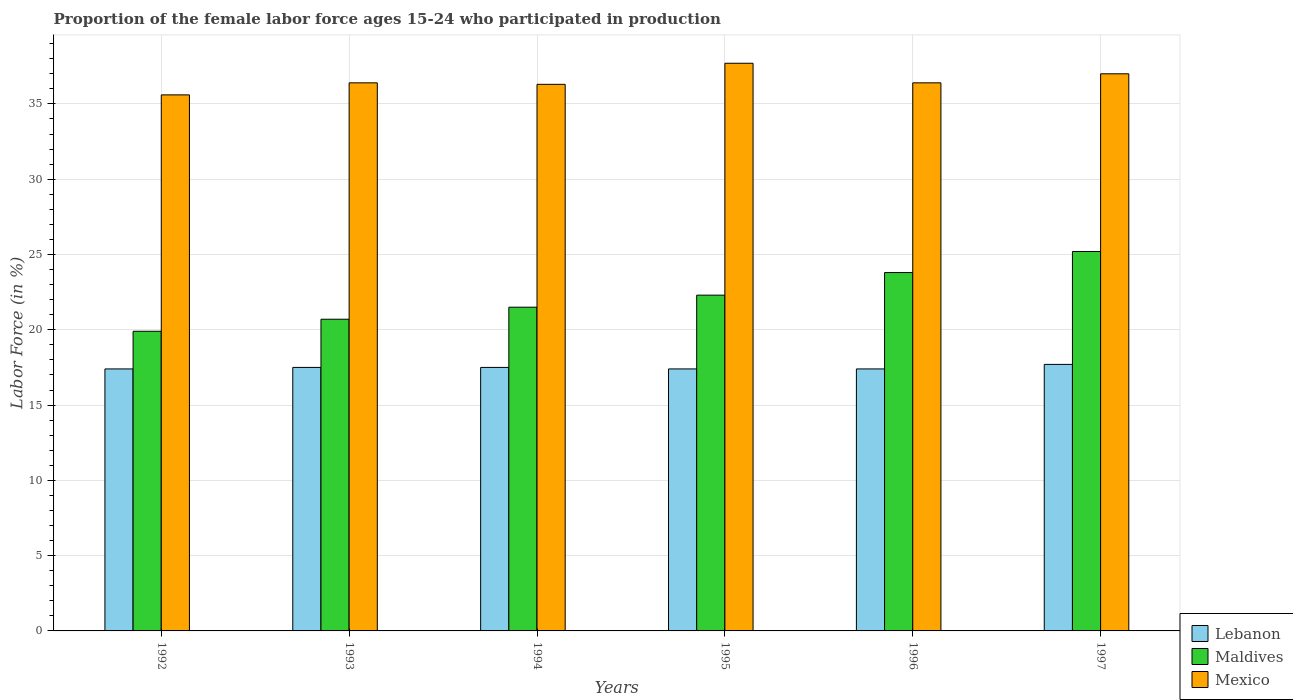How many different coloured bars are there?
Keep it short and to the point. 3. Are the number of bars per tick equal to the number of legend labels?
Provide a short and direct response. Yes. How many bars are there on the 2nd tick from the left?
Ensure brevity in your answer.  3. How many bars are there on the 4th tick from the right?
Give a very brief answer. 3. What is the proportion of the female labor force who participated in production in Mexico in 1994?
Make the answer very short. 36.3. Across all years, what is the maximum proportion of the female labor force who participated in production in Lebanon?
Give a very brief answer. 17.7. Across all years, what is the minimum proportion of the female labor force who participated in production in Maldives?
Keep it short and to the point. 19.9. In which year was the proportion of the female labor force who participated in production in Lebanon minimum?
Make the answer very short. 1992. What is the total proportion of the female labor force who participated in production in Lebanon in the graph?
Offer a terse response. 104.9. What is the difference between the proportion of the female labor force who participated in production in Maldives in 1992 and that in 1996?
Offer a very short reply. -3.9. What is the difference between the proportion of the female labor force who participated in production in Maldives in 1996 and the proportion of the female labor force who participated in production in Mexico in 1995?
Offer a very short reply. -13.9. What is the average proportion of the female labor force who participated in production in Lebanon per year?
Offer a terse response. 17.48. In the year 1994, what is the difference between the proportion of the female labor force who participated in production in Mexico and proportion of the female labor force who participated in production in Lebanon?
Offer a very short reply. 18.8. What is the ratio of the proportion of the female labor force who participated in production in Mexico in 1993 to that in 1996?
Ensure brevity in your answer.  1. What is the difference between the highest and the second highest proportion of the female labor force who participated in production in Maldives?
Ensure brevity in your answer.  1.4. What is the difference between the highest and the lowest proportion of the female labor force who participated in production in Maldives?
Your answer should be compact. 5.3. What does the 2nd bar from the left in 1995 represents?
Ensure brevity in your answer.  Maldives. What does the 2nd bar from the right in 1992 represents?
Your answer should be very brief. Maldives. Is it the case that in every year, the sum of the proportion of the female labor force who participated in production in Maldives and proportion of the female labor force who participated in production in Mexico is greater than the proportion of the female labor force who participated in production in Lebanon?
Ensure brevity in your answer.  Yes. Are all the bars in the graph horizontal?
Your answer should be compact. No. Does the graph contain any zero values?
Offer a terse response. No. What is the title of the graph?
Offer a very short reply. Proportion of the female labor force ages 15-24 who participated in production. What is the label or title of the Y-axis?
Offer a very short reply. Labor Force (in %). What is the Labor Force (in %) in Lebanon in 1992?
Your answer should be very brief. 17.4. What is the Labor Force (in %) in Maldives in 1992?
Give a very brief answer. 19.9. What is the Labor Force (in %) of Mexico in 1992?
Offer a very short reply. 35.6. What is the Labor Force (in %) in Lebanon in 1993?
Keep it short and to the point. 17.5. What is the Labor Force (in %) in Maldives in 1993?
Your response must be concise. 20.7. What is the Labor Force (in %) of Mexico in 1993?
Offer a terse response. 36.4. What is the Labor Force (in %) of Mexico in 1994?
Offer a very short reply. 36.3. What is the Labor Force (in %) in Lebanon in 1995?
Your answer should be compact. 17.4. What is the Labor Force (in %) in Maldives in 1995?
Provide a succinct answer. 22.3. What is the Labor Force (in %) in Mexico in 1995?
Your response must be concise. 37.7. What is the Labor Force (in %) in Lebanon in 1996?
Provide a succinct answer. 17.4. What is the Labor Force (in %) of Maldives in 1996?
Ensure brevity in your answer.  23.8. What is the Labor Force (in %) of Mexico in 1996?
Ensure brevity in your answer.  36.4. What is the Labor Force (in %) of Lebanon in 1997?
Make the answer very short. 17.7. What is the Labor Force (in %) of Maldives in 1997?
Your answer should be compact. 25.2. What is the Labor Force (in %) of Mexico in 1997?
Provide a short and direct response. 37. Across all years, what is the maximum Labor Force (in %) in Lebanon?
Make the answer very short. 17.7. Across all years, what is the maximum Labor Force (in %) of Maldives?
Your answer should be very brief. 25.2. Across all years, what is the maximum Labor Force (in %) in Mexico?
Offer a terse response. 37.7. Across all years, what is the minimum Labor Force (in %) of Lebanon?
Your answer should be very brief. 17.4. Across all years, what is the minimum Labor Force (in %) in Maldives?
Keep it short and to the point. 19.9. Across all years, what is the minimum Labor Force (in %) in Mexico?
Ensure brevity in your answer.  35.6. What is the total Labor Force (in %) of Lebanon in the graph?
Ensure brevity in your answer.  104.9. What is the total Labor Force (in %) of Maldives in the graph?
Provide a short and direct response. 133.4. What is the total Labor Force (in %) in Mexico in the graph?
Your response must be concise. 219.4. What is the difference between the Labor Force (in %) of Lebanon in 1992 and that in 1995?
Ensure brevity in your answer.  0. What is the difference between the Labor Force (in %) in Mexico in 1992 and that in 1995?
Give a very brief answer. -2.1. What is the difference between the Labor Force (in %) in Mexico in 1992 and that in 1997?
Make the answer very short. -1.4. What is the difference between the Labor Force (in %) in Lebanon in 1993 and that in 1994?
Your response must be concise. 0. What is the difference between the Labor Force (in %) of Mexico in 1993 and that in 1994?
Your answer should be compact. 0.1. What is the difference between the Labor Force (in %) of Lebanon in 1993 and that in 1995?
Keep it short and to the point. 0.1. What is the difference between the Labor Force (in %) of Mexico in 1993 and that in 1996?
Your answer should be very brief. 0. What is the difference between the Labor Force (in %) in Lebanon in 1993 and that in 1997?
Make the answer very short. -0.2. What is the difference between the Labor Force (in %) in Mexico in 1993 and that in 1997?
Offer a terse response. -0.6. What is the difference between the Labor Force (in %) in Lebanon in 1994 and that in 1995?
Offer a terse response. 0.1. What is the difference between the Labor Force (in %) of Maldives in 1994 and that in 1995?
Keep it short and to the point. -0.8. What is the difference between the Labor Force (in %) in Lebanon in 1994 and that in 1997?
Your answer should be very brief. -0.2. What is the difference between the Labor Force (in %) in Mexico in 1994 and that in 1997?
Your response must be concise. -0.7. What is the difference between the Labor Force (in %) of Maldives in 1995 and that in 1996?
Your response must be concise. -1.5. What is the difference between the Labor Force (in %) in Mexico in 1995 and that in 1996?
Give a very brief answer. 1.3. What is the difference between the Labor Force (in %) in Lebanon in 1995 and that in 1997?
Ensure brevity in your answer.  -0.3. What is the difference between the Labor Force (in %) in Lebanon in 1996 and that in 1997?
Give a very brief answer. -0.3. What is the difference between the Labor Force (in %) of Maldives in 1996 and that in 1997?
Your answer should be compact. -1.4. What is the difference between the Labor Force (in %) in Lebanon in 1992 and the Labor Force (in %) in Maldives in 1993?
Ensure brevity in your answer.  -3.3. What is the difference between the Labor Force (in %) in Lebanon in 1992 and the Labor Force (in %) in Mexico in 1993?
Give a very brief answer. -19. What is the difference between the Labor Force (in %) of Maldives in 1992 and the Labor Force (in %) of Mexico in 1993?
Make the answer very short. -16.5. What is the difference between the Labor Force (in %) of Lebanon in 1992 and the Labor Force (in %) of Maldives in 1994?
Keep it short and to the point. -4.1. What is the difference between the Labor Force (in %) of Lebanon in 1992 and the Labor Force (in %) of Mexico in 1994?
Ensure brevity in your answer.  -18.9. What is the difference between the Labor Force (in %) in Maldives in 1992 and the Labor Force (in %) in Mexico in 1994?
Your answer should be very brief. -16.4. What is the difference between the Labor Force (in %) of Lebanon in 1992 and the Labor Force (in %) of Mexico in 1995?
Offer a terse response. -20.3. What is the difference between the Labor Force (in %) of Maldives in 1992 and the Labor Force (in %) of Mexico in 1995?
Give a very brief answer. -17.8. What is the difference between the Labor Force (in %) of Maldives in 1992 and the Labor Force (in %) of Mexico in 1996?
Make the answer very short. -16.5. What is the difference between the Labor Force (in %) of Lebanon in 1992 and the Labor Force (in %) of Mexico in 1997?
Ensure brevity in your answer.  -19.6. What is the difference between the Labor Force (in %) of Maldives in 1992 and the Labor Force (in %) of Mexico in 1997?
Your answer should be compact. -17.1. What is the difference between the Labor Force (in %) of Lebanon in 1993 and the Labor Force (in %) of Maldives in 1994?
Make the answer very short. -4. What is the difference between the Labor Force (in %) of Lebanon in 1993 and the Labor Force (in %) of Mexico in 1994?
Keep it short and to the point. -18.8. What is the difference between the Labor Force (in %) of Maldives in 1993 and the Labor Force (in %) of Mexico in 1994?
Ensure brevity in your answer.  -15.6. What is the difference between the Labor Force (in %) of Lebanon in 1993 and the Labor Force (in %) of Mexico in 1995?
Give a very brief answer. -20.2. What is the difference between the Labor Force (in %) of Lebanon in 1993 and the Labor Force (in %) of Mexico in 1996?
Give a very brief answer. -18.9. What is the difference between the Labor Force (in %) in Maldives in 1993 and the Labor Force (in %) in Mexico in 1996?
Offer a terse response. -15.7. What is the difference between the Labor Force (in %) of Lebanon in 1993 and the Labor Force (in %) of Mexico in 1997?
Give a very brief answer. -19.5. What is the difference between the Labor Force (in %) of Maldives in 1993 and the Labor Force (in %) of Mexico in 1997?
Provide a short and direct response. -16.3. What is the difference between the Labor Force (in %) in Lebanon in 1994 and the Labor Force (in %) in Maldives in 1995?
Give a very brief answer. -4.8. What is the difference between the Labor Force (in %) in Lebanon in 1994 and the Labor Force (in %) in Mexico in 1995?
Ensure brevity in your answer.  -20.2. What is the difference between the Labor Force (in %) in Maldives in 1994 and the Labor Force (in %) in Mexico in 1995?
Offer a terse response. -16.2. What is the difference between the Labor Force (in %) of Lebanon in 1994 and the Labor Force (in %) of Mexico in 1996?
Make the answer very short. -18.9. What is the difference between the Labor Force (in %) of Maldives in 1994 and the Labor Force (in %) of Mexico in 1996?
Provide a succinct answer. -14.9. What is the difference between the Labor Force (in %) in Lebanon in 1994 and the Labor Force (in %) in Maldives in 1997?
Your answer should be very brief. -7.7. What is the difference between the Labor Force (in %) in Lebanon in 1994 and the Labor Force (in %) in Mexico in 1997?
Provide a short and direct response. -19.5. What is the difference between the Labor Force (in %) in Maldives in 1994 and the Labor Force (in %) in Mexico in 1997?
Provide a short and direct response. -15.5. What is the difference between the Labor Force (in %) in Lebanon in 1995 and the Labor Force (in %) in Maldives in 1996?
Offer a very short reply. -6.4. What is the difference between the Labor Force (in %) of Lebanon in 1995 and the Labor Force (in %) of Mexico in 1996?
Ensure brevity in your answer.  -19. What is the difference between the Labor Force (in %) in Maldives in 1995 and the Labor Force (in %) in Mexico in 1996?
Offer a very short reply. -14.1. What is the difference between the Labor Force (in %) in Lebanon in 1995 and the Labor Force (in %) in Mexico in 1997?
Your answer should be compact. -19.6. What is the difference between the Labor Force (in %) in Maldives in 1995 and the Labor Force (in %) in Mexico in 1997?
Your answer should be compact. -14.7. What is the difference between the Labor Force (in %) of Lebanon in 1996 and the Labor Force (in %) of Maldives in 1997?
Make the answer very short. -7.8. What is the difference between the Labor Force (in %) in Lebanon in 1996 and the Labor Force (in %) in Mexico in 1997?
Your response must be concise. -19.6. What is the difference between the Labor Force (in %) in Maldives in 1996 and the Labor Force (in %) in Mexico in 1997?
Make the answer very short. -13.2. What is the average Labor Force (in %) in Lebanon per year?
Your response must be concise. 17.48. What is the average Labor Force (in %) of Maldives per year?
Ensure brevity in your answer.  22.23. What is the average Labor Force (in %) in Mexico per year?
Make the answer very short. 36.57. In the year 1992, what is the difference between the Labor Force (in %) in Lebanon and Labor Force (in %) in Mexico?
Keep it short and to the point. -18.2. In the year 1992, what is the difference between the Labor Force (in %) in Maldives and Labor Force (in %) in Mexico?
Your answer should be very brief. -15.7. In the year 1993, what is the difference between the Labor Force (in %) in Lebanon and Labor Force (in %) in Mexico?
Provide a succinct answer. -18.9. In the year 1993, what is the difference between the Labor Force (in %) in Maldives and Labor Force (in %) in Mexico?
Your response must be concise. -15.7. In the year 1994, what is the difference between the Labor Force (in %) of Lebanon and Labor Force (in %) of Maldives?
Keep it short and to the point. -4. In the year 1994, what is the difference between the Labor Force (in %) in Lebanon and Labor Force (in %) in Mexico?
Keep it short and to the point. -18.8. In the year 1994, what is the difference between the Labor Force (in %) in Maldives and Labor Force (in %) in Mexico?
Give a very brief answer. -14.8. In the year 1995, what is the difference between the Labor Force (in %) of Lebanon and Labor Force (in %) of Maldives?
Your answer should be very brief. -4.9. In the year 1995, what is the difference between the Labor Force (in %) in Lebanon and Labor Force (in %) in Mexico?
Provide a succinct answer. -20.3. In the year 1995, what is the difference between the Labor Force (in %) in Maldives and Labor Force (in %) in Mexico?
Your response must be concise. -15.4. In the year 1996, what is the difference between the Labor Force (in %) in Lebanon and Labor Force (in %) in Maldives?
Offer a terse response. -6.4. In the year 1996, what is the difference between the Labor Force (in %) of Lebanon and Labor Force (in %) of Mexico?
Make the answer very short. -19. In the year 1996, what is the difference between the Labor Force (in %) of Maldives and Labor Force (in %) of Mexico?
Your answer should be very brief. -12.6. In the year 1997, what is the difference between the Labor Force (in %) in Lebanon and Labor Force (in %) in Maldives?
Your response must be concise. -7.5. In the year 1997, what is the difference between the Labor Force (in %) in Lebanon and Labor Force (in %) in Mexico?
Your answer should be very brief. -19.3. In the year 1997, what is the difference between the Labor Force (in %) in Maldives and Labor Force (in %) in Mexico?
Your answer should be very brief. -11.8. What is the ratio of the Labor Force (in %) of Lebanon in 1992 to that in 1993?
Ensure brevity in your answer.  0.99. What is the ratio of the Labor Force (in %) of Maldives in 1992 to that in 1993?
Offer a terse response. 0.96. What is the ratio of the Labor Force (in %) in Mexico in 1992 to that in 1993?
Your answer should be compact. 0.98. What is the ratio of the Labor Force (in %) of Maldives in 1992 to that in 1994?
Provide a short and direct response. 0.93. What is the ratio of the Labor Force (in %) of Mexico in 1992 to that in 1994?
Offer a terse response. 0.98. What is the ratio of the Labor Force (in %) in Lebanon in 1992 to that in 1995?
Provide a succinct answer. 1. What is the ratio of the Labor Force (in %) in Maldives in 1992 to that in 1995?
Make the answer very short. 0.89. What is the ratio of the Labor Force (in %) in Mexico in 1992 to that in 1995?
Your response must be concise. 0.94. What is the ratio of the Labor Force (in %) of Lebanon in 1992 to that in 1996?
Your answer should be compact. 1. What is the ratio of the Labor Force (in %) in Maldives in 1992 to that in 1996?
Offer a very short reply. 0.84. What is the ratio of the Labor Force (in %) in Mexico in 1992 to that in 1996?
Provide a short and direct response. 0.98. What is the ratio of the Labor Force (in %) in Lebanon in 1992 to that in 1997?
Offer a terse response. 0.98. What is the ratio of the Labor Force (in %) in Maldives in 1992 to that in 1997?
Your response must be concise. 0.79. What is the ratio of the Labor Force (in %) of Mexico in 1992 to that in 1997?
Keep it short and to the point. 0.96. What is the ratio of the Labor Force (in %) of Lebanon in 1993 to that in 1994?
Offer a terse response. 1. What is the ratio of the Labor Force (in %) in Maldives in 1993 to that in 1994?
Your answer should be compact. 0.96. What is the ratio of the Labor Force (in %) in Maldives in 1993 to that in 1995?
Offer a terse response. 0.93. What is the ratio of the Labor Force (in %) in Mexico in 1993 to that in 1995?
Give a very brief answer. 0.97. What is the ratio of the Labor Force (in %) of Lebanon in 1993 to that in 1996?
Provide a short and direct response. 1.01. What is the ratio of the Labor Force (in %) in Maldives in 1993 to that in 1996?
Your response must be concise. 0.87. What is the ratio of the Labor Force (in %) in Lebanon in 1993 to that in 1997?
Your response must be concise. 0.99. What is the ratio of the Labor Force (in %) in Maldives in 1993 to that in 1997?
Offer a very short reply. 0.82. What is the ratio of the Labor Force (in %) in Mexico in 1993 to that in 1997?
Give a very brief answer. 0.98. What is the ratio of the Labor Force (in %) in Lebanon in 1994 to that in 1995?
Ensure brevity in your answer.  1.01. What is the ratio of the Labor Force (in %) in Maldives in 1994 to that in 1995?
Keep it short and to the point. 0.96. What is the ratio of the Labor Force (in %) in Mexico in 1994 to that in 1995?
Provide a short and direct response. 0.96. What is the ratio of the Labor Force (in %) in Maldives in 1994 to that in 1996?
Ensure brevity in your answer.  0.9. What is the ratio of the Labor Force (in %) of Lebanon in 1994 to that in 1997?
Make the answer very short. 0.99. What is the ratio of the Labor Force (in %) of Maldives in 1994 to that in 1997?
Give a very brief answer. 0.85. What is the ratio of the Labor Force (in %) in Mexico in 1994 to that in 1997?
Provide a short and direct response. 0.98. What is the ratio of the Labor Force (in %) of Maldives in 1995 to that in 1996?
Provide a succinct answer. 0.94. What is the ratio of the Labor Force (in %) in Mexico in 1995 to that in 1996?
Your answer should be very brief. 1.04. What is the ratio of the Labor Force (in %) in Lebanon in 1995 to that in 1997?
Offer a terse response. 0.98. What is the ratio of the Labor Force (in %) in Maldives in 1995 to that in 1997?
Ensure brevity in your answer.  0.88. What is the ratio of the Labor Force (in %) in Mexico in 1995 to that in 1997?
Make the answer very short. 1.02. What is the ratio of the Labor Force (in %) of Lebanon in 1996 to that in 1997?
Offer a terse response. 0.98. What is the ratio of the Labor Force (in %) in Maldives in 1996 to that in 1997?
Your answer should be compact. 0.94. What is the ratio of the Labor Force (in %) in Mexico in 1996 to that in 1997?
Offer a terse response. 0.98. What is the difference between the highest and the second highest Labor Force (in %) in Maldives?
Keep it short and to the point. 1.4. What is the difference between the highest and the second highest Labor Force (in %) in Mexico?
Ensure brevity in your answer.  0.7. What is the difference between the highest and the lowest Labor Force (in %) of Maldives?
Your answer should be compact. 5.3. 